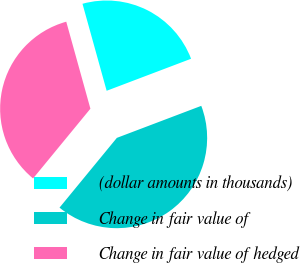Convert chart. <chart><loc_0><loc_0><loc_500><loc_500><pie_chart><fcel>(dollar amounts in thousands)<fcel>Change in fair value of<fcel>Change in fair value of hedged<nl><fcel>23.54%<fcel>41.72%<fcel>34.74%<nl></chart> 